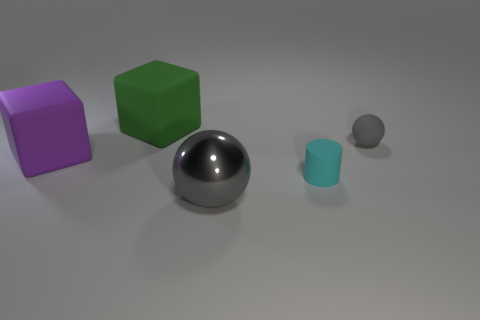Subtract all purple cubes. How many cubes are left? 1 Subtract all cubes. How many objects are left? 3 Add 4 big green things. How many big green things are left? 5 Add 5 big yellow shiny cubes. How many big yellow shiny cubes exist? 5 Add 3 large purple objects. How many objects exist? 8 Subtract 1 cyan cylinders. How many objects are left? 4 Subtract 1 cylinders. How many cylinders are left? 0 Subtract all blue spheres. Subtract all purple cubes. How many spheres are left? 2 Subtract all yellow cylinders. How many green cubes are left? 1 Subtract all large purple rubber cubes. Subtract all tiny gray matte things. How many objects are left? 3 